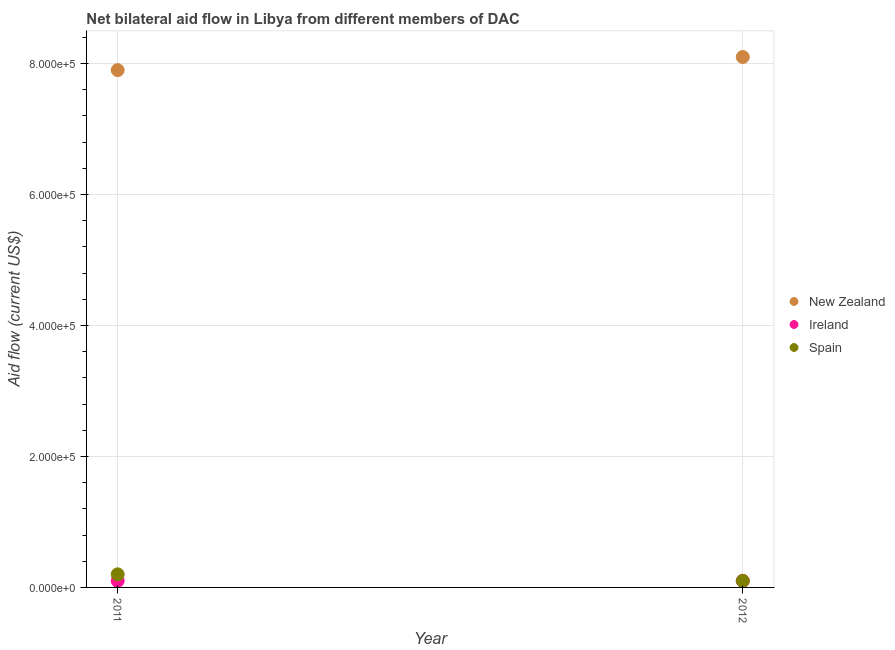What is the amount of aid provided by ireland in 2011?
Give a very brief answer. 10000. Across all years, what is the maximum amount of aid provided by ireland?
Your response must be concise. 10000. Across all years, what is the minimum amount of aid provided by ireland?
Make the answer very short. 10000. In which year was the amount of aid provided by new zealand minimum?
Offer a very short reply. 2011. What is the total amount of aid provided by spain in the graph?
Make the answer very short. 3.00e+04. What is the difference between the amount of aid provided by new zealand in 2011 and that in 2012?
Your answer should be compact. -2.00e+04. What is the difference between the amount of aid provided by ireland in 2011 and the amount of aid provided by new zealand in 2012?
Your answer should be very brief. -8.00e+05. What is the average amount of aid provided by new zealand per year?
Give a very brief answer. 8.00e+05. In the year 2011, what is the difference between the amount of aid provided by spain and amount of aid provided by new zealand?
Keep it short and to the point. -7.70e+05. In how many years, is the amount of aid provided by spain greater than 360000 US$?
Provide a short and direct response. 0. What is the ratio of the amount of aid provided by new zealand in 2011 to that in 2012?
Offer a terse response. 0.98. In how many years, is the amount of aid provided by spain greater than the average amount of aid provided by spain taken over all years?
Ensure brevity in your answer.  1. Does the amount of aid provided by spain monotonically increase over the years?
Offer a terse response. No. Is the amount of aid provided by new zealand strictly less than the amount of aid provided by ireland over the years?
Provide a short and direct response. No. How many years are there in the graph?
Keep it short and to the point. 2. What is the difference between two consecutive major ticks on the Y-axis?
Your answer should be very brief. 2.00e+05. Does the graph contain grids?
Provide a short and direct response. Yes. Where does the legend appear in the graph?
Give a very brief answer. Center right. How many legend labels are there?
Offer a very short reply. 3. How are the legend labels stacked?
Ensure brevity in your answer.  Vertical. What is the title of the graph?
Provide a succinct answer. Net bilateral aid flow in Libya from different members of DAC. What is the label or title of the X-axis?
Your response must be concise. Year. What is the Aid flow (current US$) of New Zealand in 2011?
Your answer should be very brief. 7.90e+05. What is the Aid flow (current US$) of Ireland in 2011?
Offer a terse response. 10000. What is the Aid flow (current US$) of Spain in 2011?
Offer a terse response. 2.00e+04. What is the Aid flow (current US$) of New Zealand in 2012?
Provide a succinct answer. 8.10e+05. What is the Aid flow (current US$) of Spain in 2012?
Give a very brief answer. 10000. Across all years, what is the maximum Aid flow (current US$) of New Zealand?
Give a very brief answer. 8.10e+05. Across all years, what is the minimum Aid flow (current US$) in New Zealand?
Offer a terse response. 7.90e+05. Across all years, what is the minimum Aid flow (current US$) in Ireland?
Provide a succinct answer. 10000. What is the total Aid flow (current US$) in New Zealand in the graph?
Keep it short and to the point. 1.60e+06. What is the total Aid flow (current US$) in Ireland in the graph?
Provide a succinct answer. 2.00e+04. What is the total Aid flow (current US$) in Spain in the graph?
Offer a very short reply. 3.00e+04. What is the difference between the Aid flow (current US$) of Ireland in 2011 and that in 2012?
Your response must be concise. 0. What is the difference between the Aid flow (current US$) in New Zealand in 2011 and the Aid flow (current US$) in Ireland in 2012?
Offer a very short reply. 7.80e+05. What is the difference between the Aid flow (current US$) in New Zealand in 2011 and the Aid flow (current US$) in Spain in 2012?
Provide a short and direct response. 7.80e+05. What is the average Aid flow (current US$) of New Zealand per year?
Give a very brief answer. 8.00e+05. What is the average Aid flow (current US$) of Spain per year?
Your answer should be compact. 1.50e+04. In the year 2011, what is the difference between the Aid flow (current US$) of New Zealand and Aid flow (current US$) of Ireland?
Provide a succinct answer. 7.80e+05. In the year 2011, what is the difference between the Aid flow (current US$) in New Zealand and Aid flow (current US$) in Spain?
Give a very brief answer. 7.70e+05. In the year 2011, what is the difference between the Aid flow (current US$) in Ireland and Aid flow (current US$) in Spain?
Provide a succinct answer. -10000. In the year 2012, what is the difference between the Aid flow (current US$) of New Zealand and Aid flow (current US$) of Ireland?
Your response must be concise. 8.00e+05. In the year 2012, what is the difference between the Aid flow (current US$) in New Zealand and Aid flow (current US$) in Spain?
Your response must be concise. 8.00e+05. What is the ratio of the Aid flow (current US$) of New Zealand in 2011 to that in 2012?
Your answer should be compact. 0.98. What is the ratio of the Aid flow (current US$) in Ireland in 2011 to that in 2012?
Ensure brevity in your answer.  1. What is the ratio of the Aid flow (current US$) of Spain in 2011 to that in 2012?
Ensure brevity in your answer.  2. What is the difference between the highest and the lowest Aid flow (current US$) in New Zealand?
Offer a very short reply. 2.00e+04. 